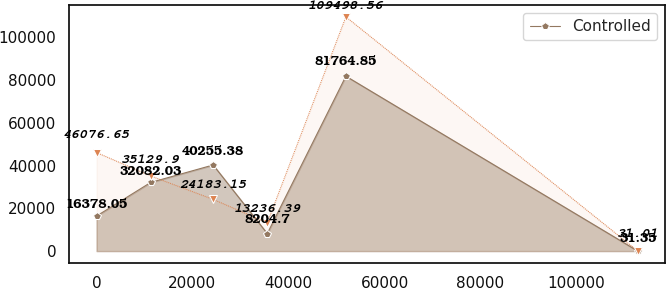<chart> <loc_0><loc_0><loc_500><loc_500><line_chart><ecel><fcel>Controlled<fcel>Unnamed: 2<nl><fcel>43.33<fcel>16378<fcel>46076.7<nl><fcel>11312.3<fcel>32082<fcel>35129.9<nl><fcel>24328.2<fcel>40255.4<fcel>24183.2<nl><fcel>35597.1<fcel>8204.7<fcel>13236.4<nl><fcel>51961.7<fcel>81764.9<fcel>109499<nl><fcel>112733<fcel>31.35<fcel>31.01<nl></chart> 